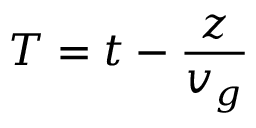<formula> <loc_0><loc_0><loc_500><loc_500>T = t - \frac { z } { v _ { g } }</formula> 